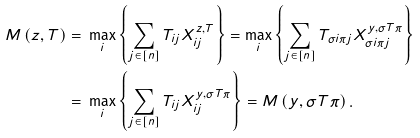Convert formula to latex. <formula><loc_0><loc_0><loc_500><loc_500>M \left ( z , T \right ) = & \ \max _ { i } \left \{ \sum _ { j \in [ n ] } T _ { i j } X ^ { z , T } _ { i j } \right \} = \max _ { i } \left \{ \sum _ { j \in [ n ] } T _ { \sigma i \pi j } X ^ { y , \sigma T \pi } _ { \sigma i \pi j } \right \} \\ = & \ \max _ { i } \left \{ \sum _ { j \in [ n ] } T _ { i j } X ^ { y , \sigma T \pi } _ { i j } \right \} = M \left ( y , \sigma T \pi \right ) .</formula> 